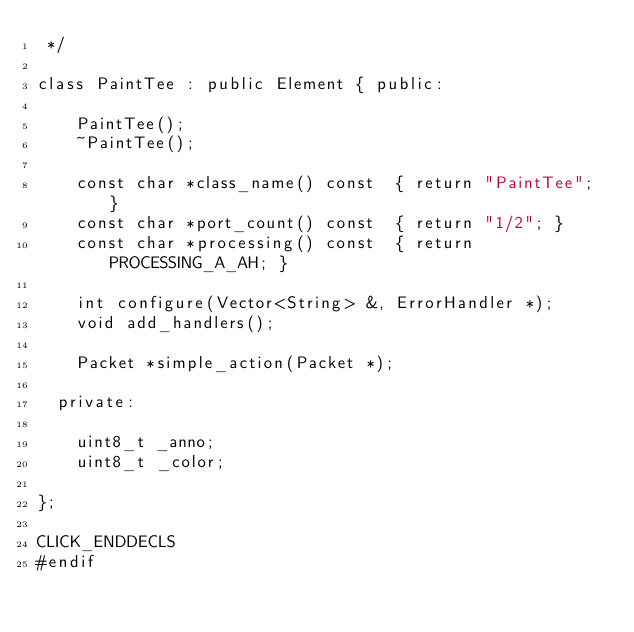Convert code to text. <code><loc_0><loc_0><loc_500><loc_500><_C++_> */

class PaintTee : public Element { public:

    PaintTee();
    ~PaintTee();

    const char *class_name() const	{ return "PaintTee"; }
    const char *port_count() const	{ return "1/2"; }
    const char *processing() const	{ return PROCESSING_A_AH; }

    int configure(Vector<String> &, ErrorHandler *);
    void add_handlers();

    Packet *simple_action(Packet *);

  private:

    uint8_t _anno;
    uint8_t _color;

};

CLICK_ENDDECLS
#endif
</code> 